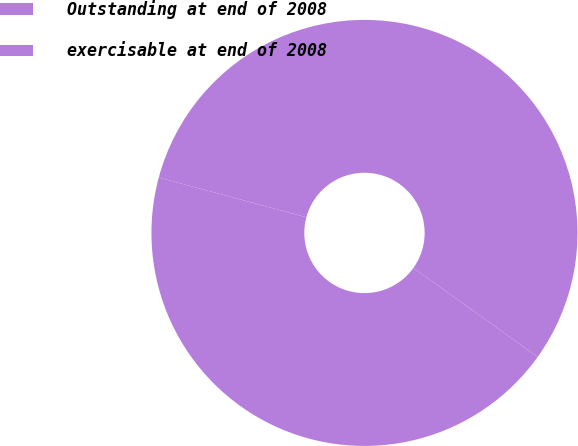Convert chart to OTSL. <chart><loc_0><loc_0><loc_500><loc_500><pie_chart><fcel>Outstanding at end of 2008<fcel>exercisable at end of 2008<nl><fcel>55.7%<fcel>44.3%<nl></chart> 